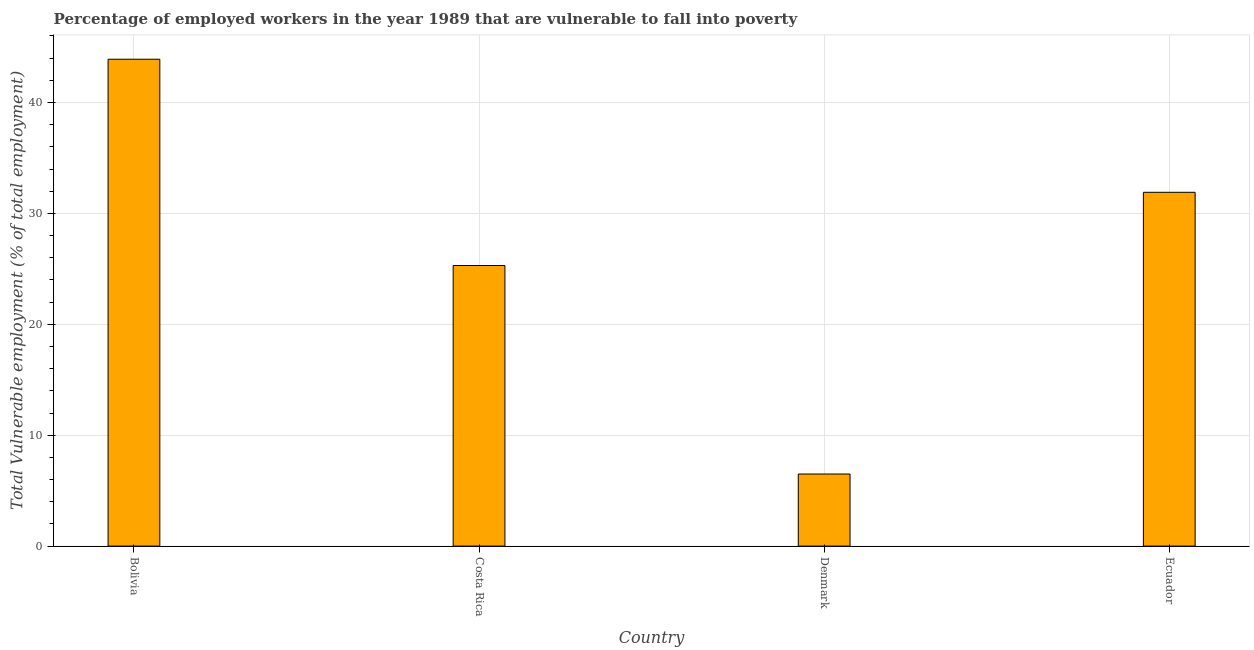Does the graph contain grids?
Offer a terse response. Yes. What is the title of the graph?
Provide a succinct answer. Percentage of employed workers in the year 1989 that are vulnerable to fall into poverty. What is the label or title of the Y-axis?
Ensure brevity in your answer.  Total Vulnerable employment (% of total employment). What is the total vulnerable employment in Ecuador?
Your answer should be compact. 31.9. Across all countries, what is the maximum total vulnerable employment?
Provide a succinct answer. 43.9. Across all countries, what is the minimum total vulnerable employment?
Your answer should be very brief. 6.5. In which country was the total vulnerable employment minimum?
Offer a very short reply. Denmark. What is the sum of the total vulnerable employment?
Your response must be concise. 107.6. What is the difference between the total vulnerable employment in Bolivia and Costa Rica?
Your answer should be very brief. 18.6. What is the average total vulnerable employment per country?
Make the answer very short. 26.9. What is the median total vulnerable employment?
Make the answer very short. 28.6. In how many countries, is the total vulnerable employment greater than 8 %?
Ensure brevity in your answer.  3. What is the ratio of the total vulnerable employment in Bolivia to that in Costa Rica?
Keep it short and to the point. 1.74. Is the total vulnerable employment in Costa Rica less than that in Denmark?
Offer a terse response. No. Is the sum of the total vulnerable employment in Bolivia and Costa Rica greater than the maximum total vulnerable employment across all countries?
Your answer should be compact. Yes. What is the difference between the highest and the lowest total vulnerable employment?
Ensure brevity in your answer.  37.4. How many bars are there?
Your answer should be very brief. 4. Are all the bars in the graph horizontal?
Give a very brief answer. No. How many countries are there in the graph?
Give a very brief answer. 4. Are the values on the major ticks of Y-axis written in scientific E-notation?
Your answer should be very brief. No. What is the Total Vulnerable employment (% of total employment) of Bolivia?
Provide a succinct answer. 43.9. What is the Total Vulnerable employment (% of total employment) in Costa Rica?
Keep it short and to the point. 25.3. What is the Total Vulnerable employment (% of total employment) of Ecuador?
Ensure brevity in your answer.  31.9. What is the difference between the Total Vulnerable employment (% of total employment) in Bolivia and Costa Rica?
Your answer should be very brief. 18.6. What is the difference between the Total Vulnerable employment (% of total employment) in Bolivia and Denmark?
Your answer should be compact. 37.4. What is the difference between the Total Vulnerable employment (% of total employment) in Bolivia and Ecuador?
Offer a terse response. 12. What is the difference between the Total Vulnerable employment (% of total employment) in Costa Rica and Denmark?
Offer a terse response. 18.8. What is the difference between the Total Vulnerable employment (% of total employment) in Denmark and Ecuador?
Offer a terse response. -25.4. What is the ratio of the Total Vulnerable employment (% of total employment) in Bolivia to that in Costa Rica?
Provide a short and direct response. 1.74. What is the ratio of the Total Vulnerable employment (% of total employment) in Bolivia to that in Denmark?
Offer a very short reply. 6.75. What is the ratio of the Total Vulnerable employment (% of total employment) in Bolivia to that in Ecuador?
Your answer should be compact. 1.38. What is the ratio of the Total Vulnerable employment (% of total employment) in Costa Rica to that in Denmark?
Make the answer very short. 3.89. What is the ratio of the Total Vulnerable employment (% of total employment) in Costa Rica to that in Ecuador?
Make the answer very short. 0.79. What is the ratio of the Total Vulnerable employment (% of total employment) in Denmark to that in Ecuador?
Your answer should be compact. 0.2. 